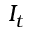Convert formula to latex. <formula><loc_0><loc_0><loc_500><loc_500>I _ { t }</formula> 